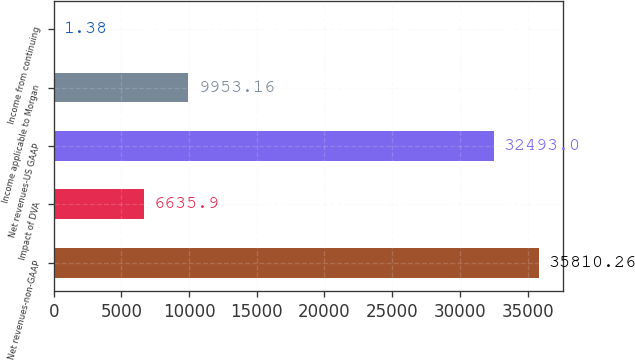Convert chart to OTSL. <chart><loc_0><loc_0><loc_500><loc_500><bar_chart><fcel>Net revenues-non-GAAP<fcel>Impact of DVA<fcel>Net revenues-US GAAP<fcel>Income applicable to Morgan<fcel>Income from continuing<nl><fcel>35810.3<fcel>6635.9<fcel>32493<fcel>9953.16<fcel>1.38<nl></chart> 